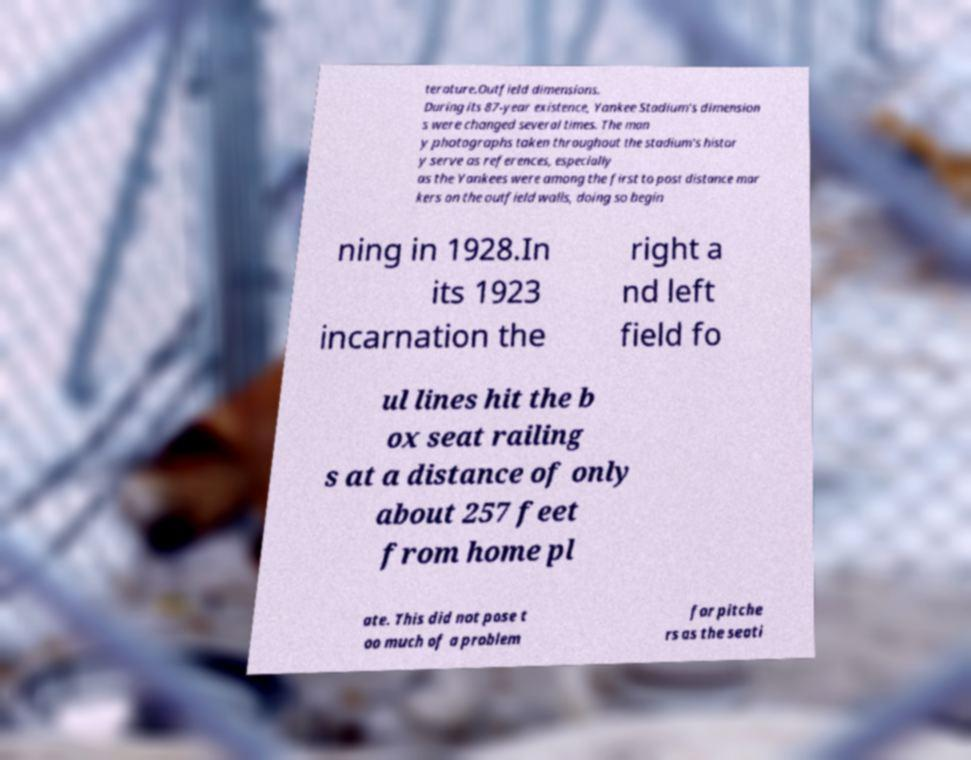Could you extract and type out the text from this image? terature.Outfield dimensions. During its 87-year existence, Yankee Stadium's dimension s were changed several times. The man y photographs taken throughout the stadium's histor y serve as references, especially as the Yankees were among the first to post distance mar kers on the outfield walls, doing so begin ning in 1928.In its 1923 incarnation the right a nd left field fo ul lines hit the b ox seat railing s at a distance of only about 257 feet from home pl ate. This did not pose t oo much of a problem for pitche rs as the seati 